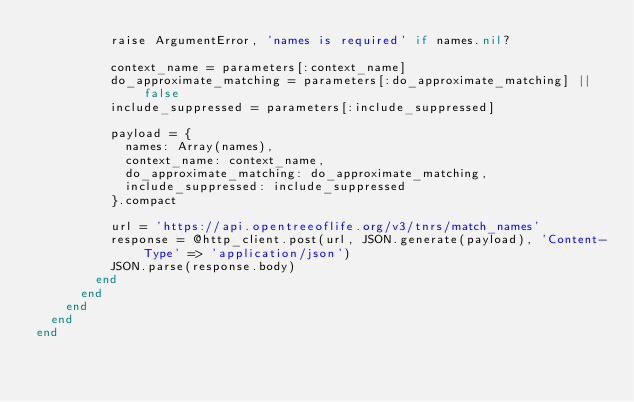<code> <loc_0><loc_0><loc_500><loc_500><_Ruby_>          raise ArgumentError, 'names is required' if names.nil?

          context_name = parameters[:context_name]
          do_approximate_matching = parameters[:do_approximate_matching] || false
          include_suppressed = parameters[:include_suppressed]

          payload = {
            names: Array(names),
            context_name: context_name,
            do_approximate_matching: do_approximate_matching,
            include_suppressed: include_suppressed
          }.compact

          url = 'https://api.opentreeoflife.org/v3/tnrs/match_names'
          response = @http_client.post(url, JSON.generate(payload), 'Content-Type' => 'application/json')
          JSON.parse(response.body)
        end
      end
    end
  end
end
</code> 